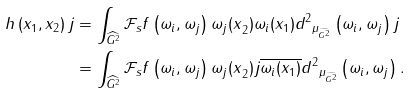<formula> <loc_0><loc_0><loc_500><loc_500>h \left ( x _ { 1 } , x _ { 2 } \right ) j & = \int _ { \widehat { G ^ { 2 } } } { { \mathcal { F } } _ { s } f \left ( \omega _ { i } , \omega _ { j } \right ) \omega _ { j } { ( x } _ { 2 } ) \omega _ { i } ( x _ { 1 } ) } { d ^ { 2 } } _ { { \mu } _ { \widehat { G ^ { 2 } } } } \left ( \omega _ { i } , \omega _ { j } \right ) j \\ & = \int _ { \widehat { G ^ { 2 } } } { { \mathcal { F } } _ { s } f \left ( \omega _ { i } , \omega _ { j } \right ) \omega _ { j } { ( x } _ { 2 } ) j \overline { \omega _ { i } ( x _ { 1 } ) } } { d ^ { 2 } } _ { { \mu } _ { \widehat { G ^ { 2 } } } } \left ( \omega _ { i } , \omega _ { j } \right ) .</formula> 